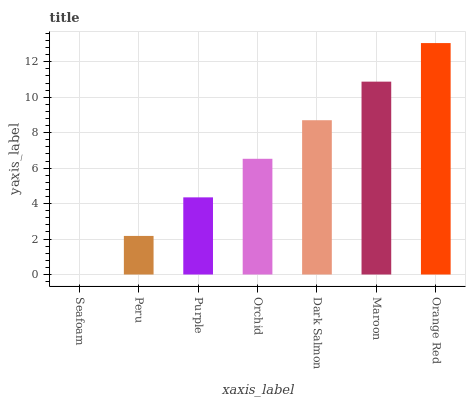Is Peru the minimum?
Answer yes or no. No. Is Peru the maximum?
Answer yes or no. No. Is Peru greater than Seafoam?
Answer yes or no. Yes. Is Seafoam less than Peru?
Answer yes or no. Yes. Is Seafoam greater than Peru?
Answer yes or no. No. Is Peru less than Seafoam?
Answer yes or no. No. Is Orchid the high median?
Answer yes or no. Yes. Is Orchid the low median?
Answer yes or no. Yes. Is Orange Red the high median?
Answer yes or no. No. Is Seafoam the low median?
Answer yes or no. No. 